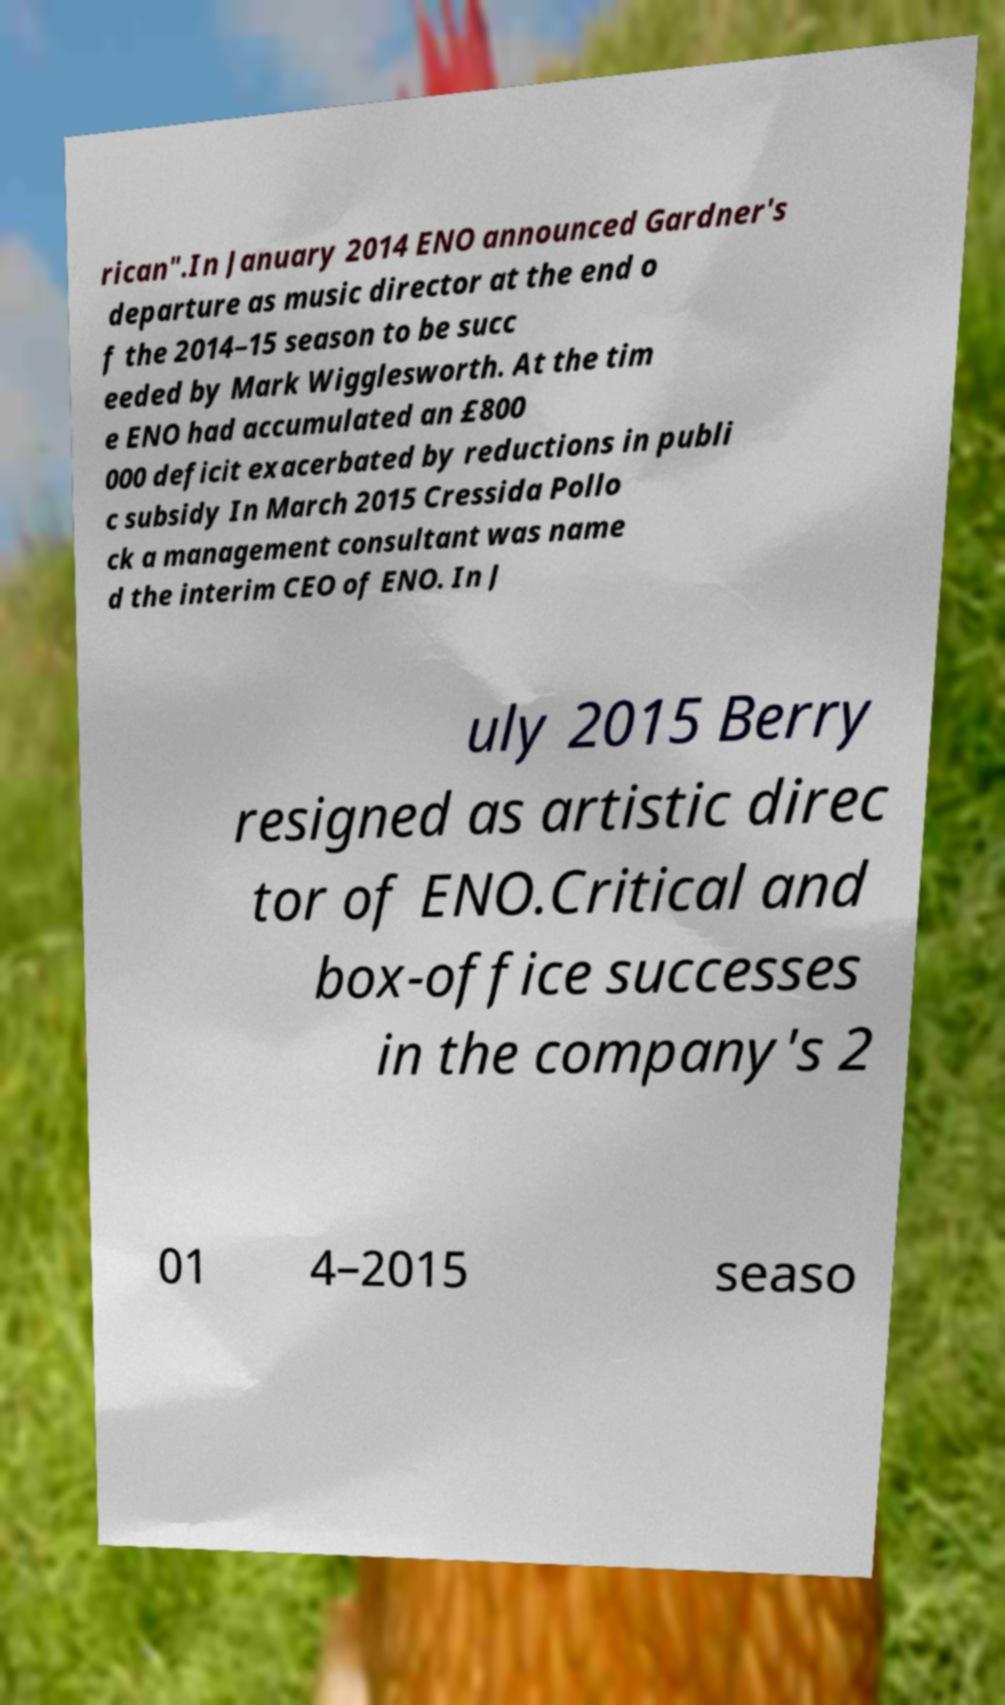Can you read and provide the text displayed in the image?This photo seems to have some interesting text. Can you extract and type it out for me? rican".In January 2014 ENO announced Gardner's departure as music director at the end o f the 2014–15 season to be succ eeded by Mark Wigglesworth. At the tim e ENO had accumulated an £800 000 deficit exacerbated by reductions in publi c subsidy In March 2015 Cressida Pollo ck a management consultant was name d the interim CEO of ENO. In J uly 2015 Berry resigned as artistic direc tor of ENO.Critical and box-office successes in the company's 2 01 4–2015 seaso 